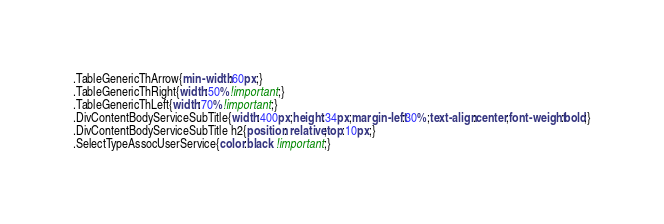<code> <loc_0><loc_0><loc_500><loc_500><_CSS_>.TableGenericThArrow{min-width:60px;}
.TableGenericThRight{width:50%!important;}
.TableGenericThLeft{width:70%!important;}
.DivContentBodyServiceSubTitle{width:400px;height:34px;margin-left:30%;text-align:center;font-weight:bold;}
.DivContentBodyServiceSubTitle h2{position: relative;top:10px;}
.SelectTypeAssocUserService{color:black !important;}</code> 